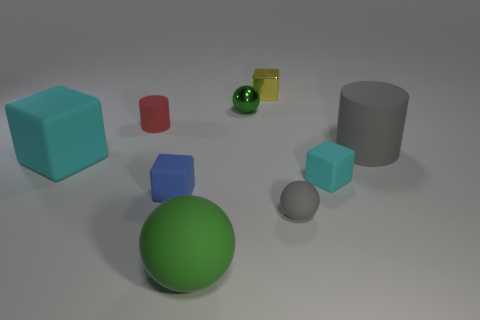What number of green things are there?
Your answer should be compact. 2. There is a small yellow thing; is its shape the same as the green object in front of the big gray cylinder?
Your answer should be very brief. No. There is a sphere that is behind the tiny rubber cylinder; what is its size?
Your answer should be compact. Small. What material is the big cyan block?
Your answer should be very brief. Rubber. Is the shape of the gray rubber thing left of the gray matte cylinder the same as  the small cyan object?
Your answer should be compact. No. The rubber ball that is the same color as the tiny metallic ball is what size?
Give a very brief answer. Large. Is there a cyan matte block that has the same size as the yellow block?
Ensure brevity in your answer.  Yes. Are there any tiny matte cubes in front of the tiny matte cube that is on the right side of the gray thing that is on the left side of the large matte cylinder?
Offer a terse response. Yes. There is a shiny sphere; is it the same color as the block behind the tiny green metal object?
Your answer should be very brief. No. What material is the cube that is behind the green object that is behind the cylinder on the right side of the tiny red matte cylinder?
Offer a very short reply. Metal. 